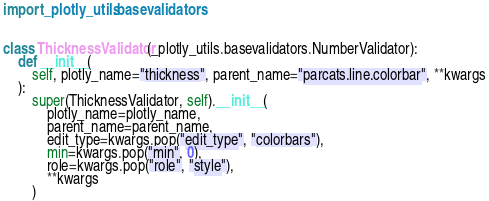Convert code to text. <code><loc_0><loc_0><loc_500><loc_500><_Python_>import _plotly_utils.basevalidators


class ThicknessValidator(_plotly_utils.basevalidators.NumberValidator):
    def __init__(
        self, plotly_name="thickness", parent_name="parcats.line.colorbar", **kwargs
    ):
        super(ThicknessValidator, self).__init__(
            plotly_name=plotly_name,
            parent_name=parent_name,
            edit_type=kwargs.pop("edit_type", "colorbars"),
            min=kwargs.pop("min", 0),
            role=kwargs.pop("role", "style"),
            **kwargs
        )
</code> 